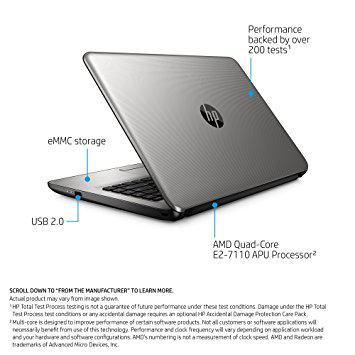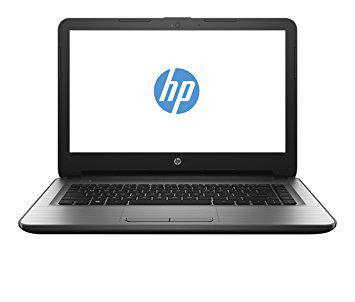The first image is the image on the left, the second image is the image on the right. Assess this claim about the two images: "There is an open laptop with a white screen displayed that features a blue circular logo". Correct or not? Answer yes or no. Yes. The first image is the image on the left, the second image is the image on the right. Considering the images on both sides, is "A laptop is turned so the screen is visible, and another laptop is turned so the back of the screen is visible." valid? Answer yes or no. Yes. 